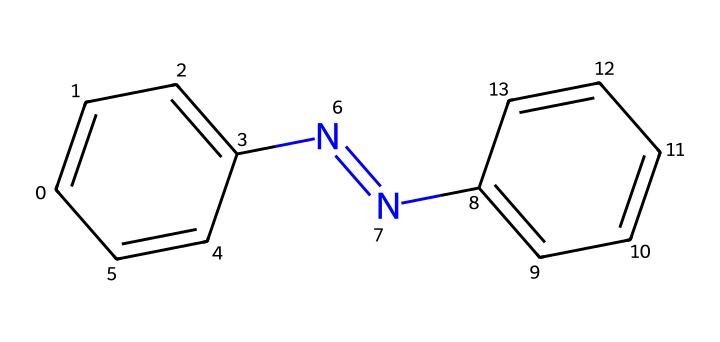What is the molecular formula of azobenzene? To find the molecular formula, we count the number of each type of atom in the structure represented by the SMILES notation. The structure has 12 carbon atoms, 10 hydrogen atoms, and 2 nitrogen atoms. Therefore, the molecular formula is C12H10N2.
Answer: C12H10N2 How many double bonds are in azobenzene? In the structure, we can identify the bonds. There are multiple double bonds: one between the nitrogen atoms (the N=N bond) and others within the phenyl rings (the C=C bonds). There are a total of 6 double bonds in azobenzene.
Answer: 6 What type of functional group is present in azobenzene? The nitrogen-nitrogen double bond (N=N) is a key feature of azobenzene and is identified as the azo group. Functional groups are specific groups of atoms responsible for the characteristic reactions of a compound. This azo group is unique to azobenzene.
Answer: azo group How many rings are in the azobenzene structure? Examining the chemical structure shows that azobenzene contains two phenyl rings, which are identified by the cyclic arrangement of carbon atoms. These rings are directly bonded to each other through a nitrogen-nitrogen double bond.
Answer: 2 What allows azobenzene to undergo photochemical reactions? The specific arrangement of atoms, particularly the presence of the azo group (N=N), allows azobenzene to undergo isomerization upon light exposure. This property is essential for its use in holographic recording as it can switch between configurations.
Answer: azo group Which atoms contribute to the stability of azobenzene? The stability in azobenzene is contributed by the resonance of the phenyl rings and the conjugated system that extends over the entire molecule. This delocalization of electrons helps stabilize the structure, especially under light exposure.
Answer: phenyl rings 